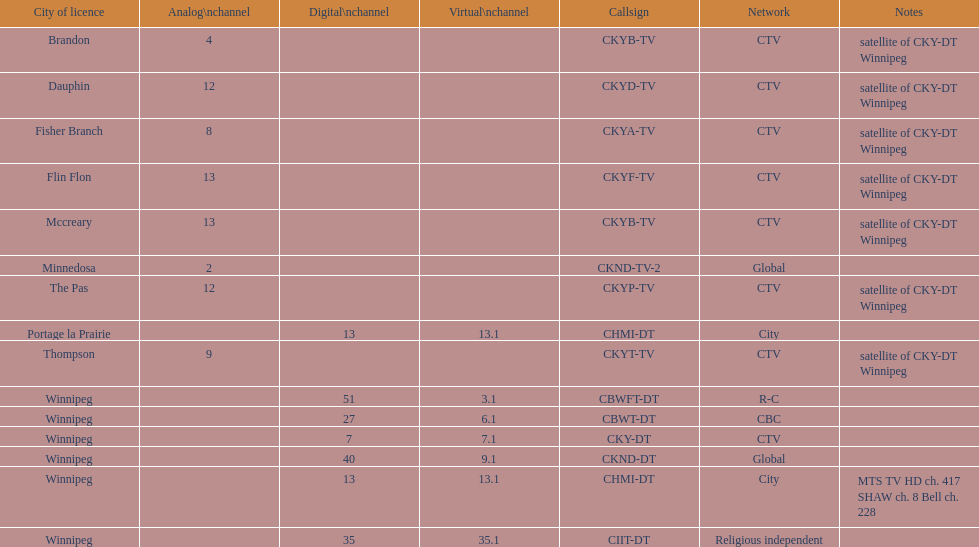Which network has the most satellite stations? CTV. 